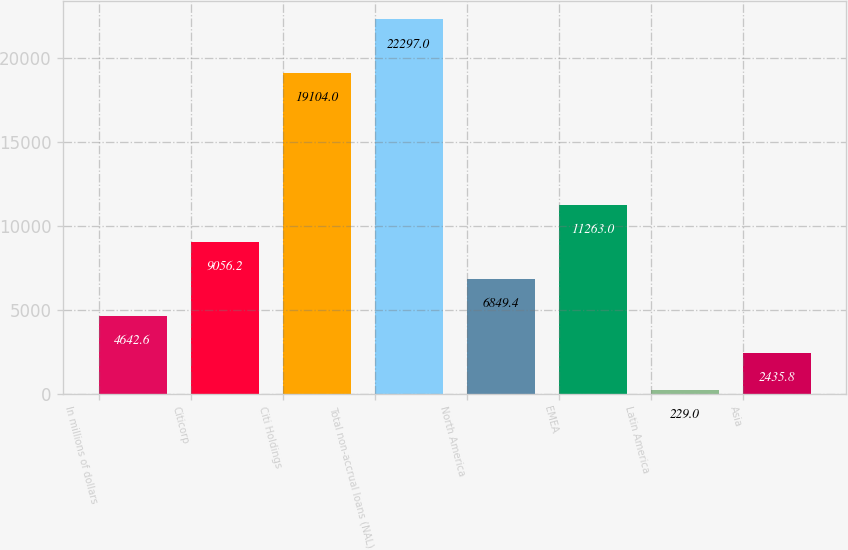Convert chart. <chart><loc_0><loc_0><loc_500><loc_500><bar_chart><fcel>In millions of dollars<fcel>Citicorp<fcel>Citi Holdings<fcel>Total non-accrual loans (NAL)<fcel>North America<fcel>EMEA<fcel>Latin America<fcel>Asia<nl><fcel>4642.6<fcel>9056.2<fcel>19104<fcel>22297<fcel>6849.4<fcel>11263<fcel>229<fcel>2435.8<nl></chart> 